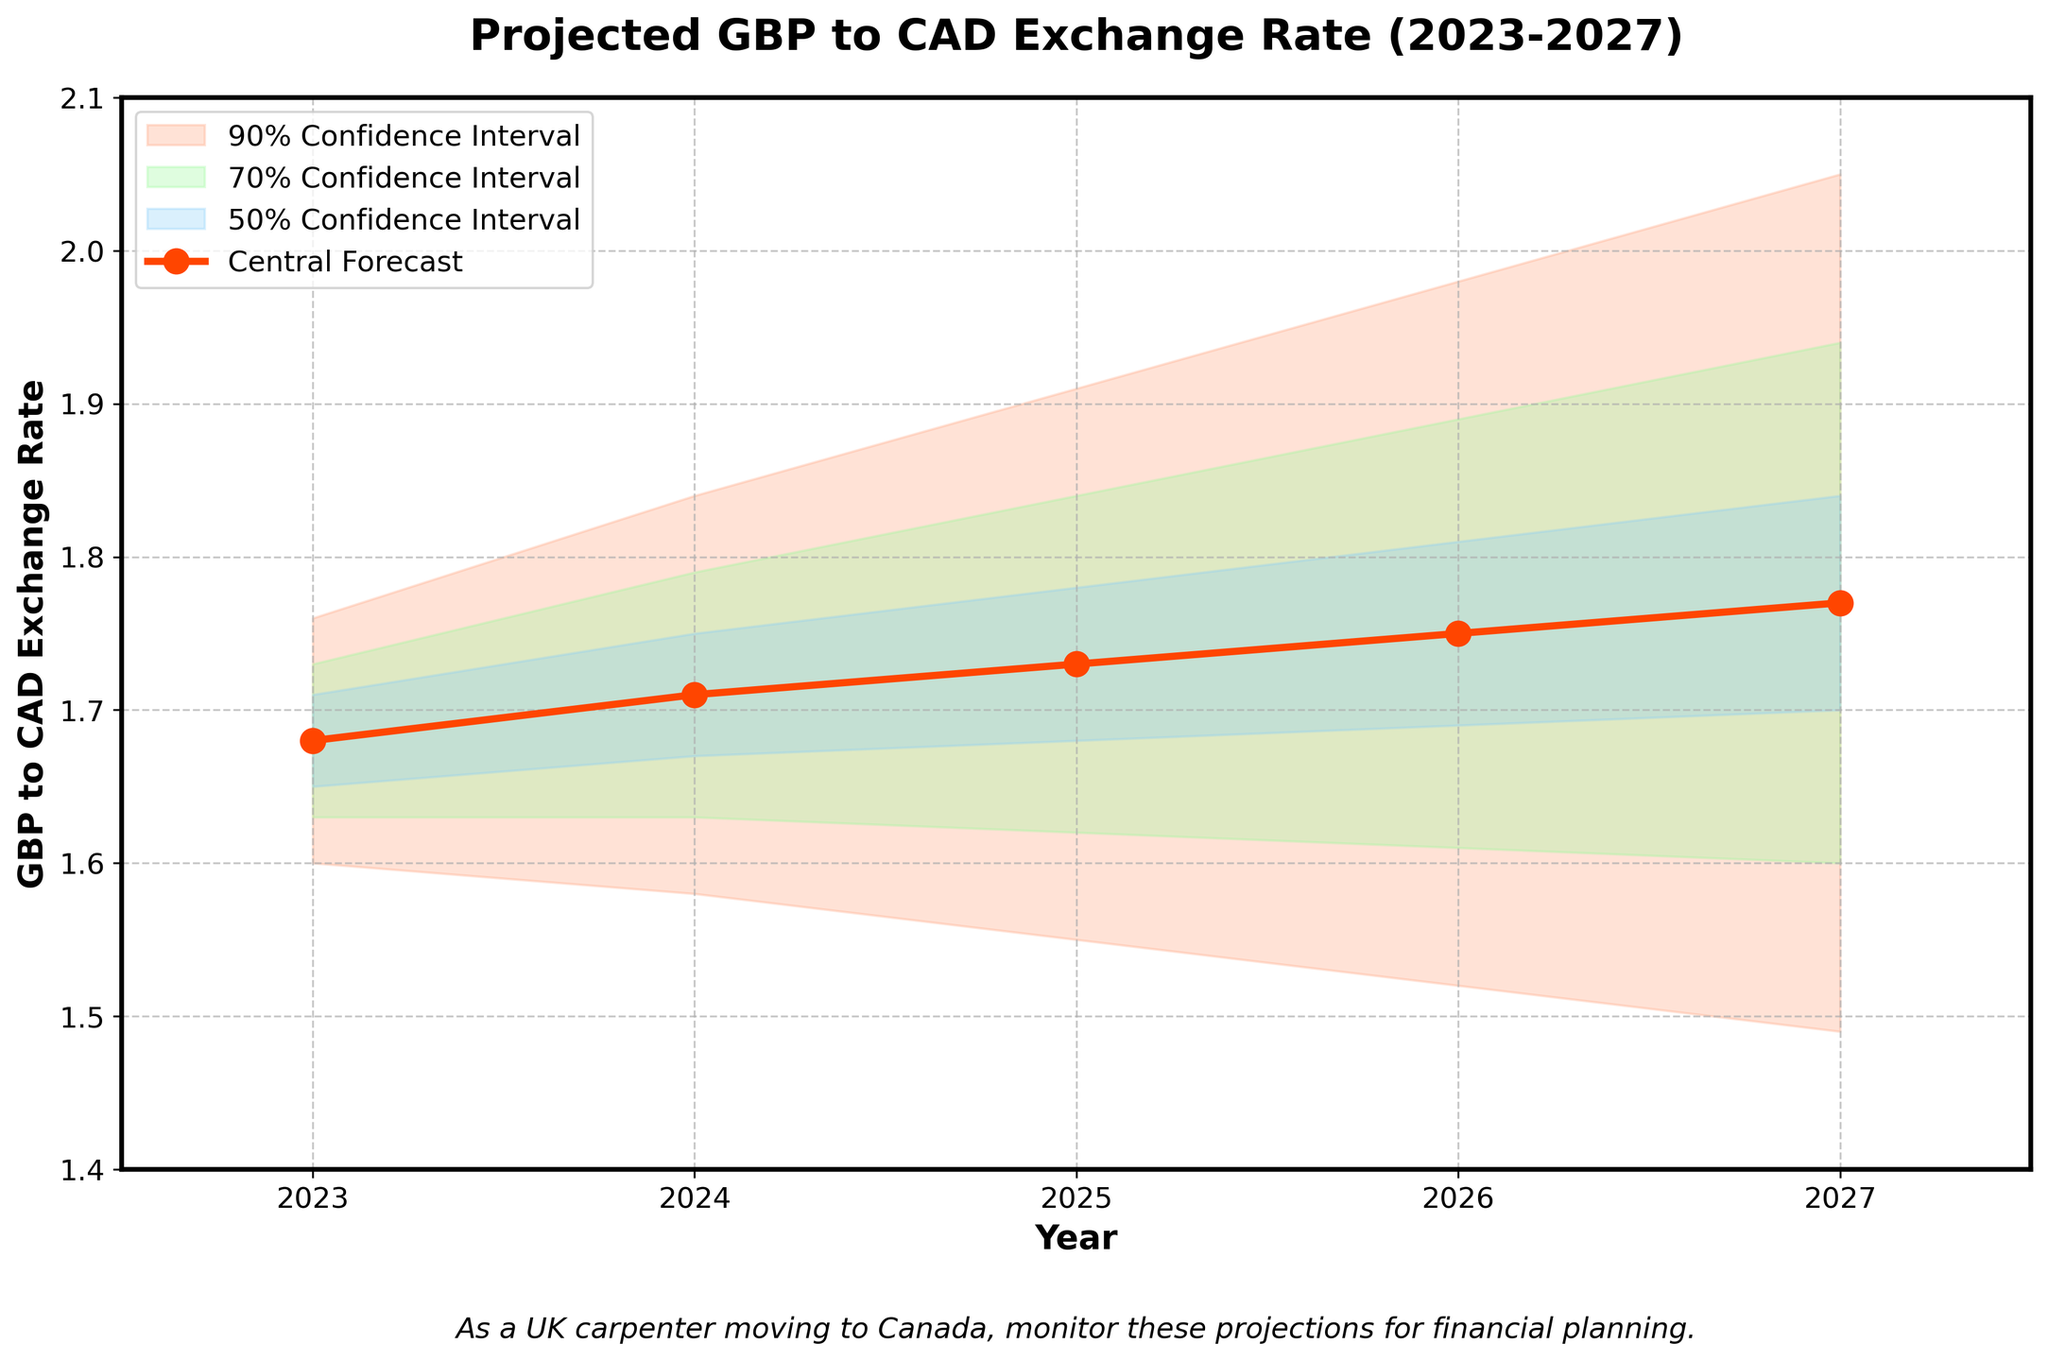What is the title of the chart? The title is usually located at the top of the chart and is typically the largest text to grab attention.
Answer: Projected GBP to CAD Exchange Rate (2023-2027) What is the central forecast value for the year 2025? Find the 2025 row and note the value under the Central Forecast column.
Answer: 1.73 Which year has the highest upper 90% confidence interval? Observe the Upper 90% confidence interval values across all years and identify the largest value.
Answer: 2027 How does the central forecast trend from 2023 to 2027? Look at the central forecast values for each year from 2023 to 2027 and describe the overall pattern.
Answer: Increasing What is the range of the lower 50% confidence interval in 2023? Subtract the Lower 50% value from the Central Forecast value for 2023 to find the range.
Answer: 0.03 In which year is the gap between the Lower 90% and Upper 90% confidence intervals the smallest? Calculate the differences between the corresponding lower and upper 90% confidence intervals for each year and compare them.
Answer: 2023 Which year shows the greatest uncertainty in the exchange rate, based on the spread between lower and upper 90% confidence intervals? Subtract the Lower 90% values from the Upper 90% values for each year and identify the largest difference.
Answer: 2027 What is the overall trend of the upper 70% confidence interval from 2023 to 2027? Observe and describe the general direction of the Upper 70% values over the years.
Answer: Increasing 